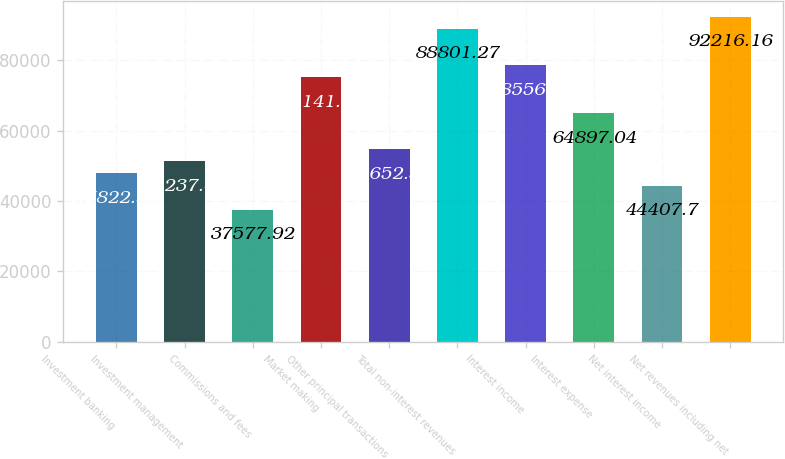Convert chart to OTSL. <chart><loc_0><loc_0><loc_500><loc_500><bar_chart><fcel>Investment banking<fcel>Investment management<fcel>Commissions and fees<fcel>Market making<fcel>Other principal transactions<fcel>Total non-interest revenues<fcel>Interest income<fcel>Interest expense<fcel>Net interest income<fcel>Net revenues including net<nl><fcel>47822.6<fcel>51237.5<fcel>37577.9<fcel>75141.7<fcel>54652.4<fcel>88801.3<fcel>78556.6<fcel>64897<fcel>44407.7<fcel>92216.2<nl></chart> 